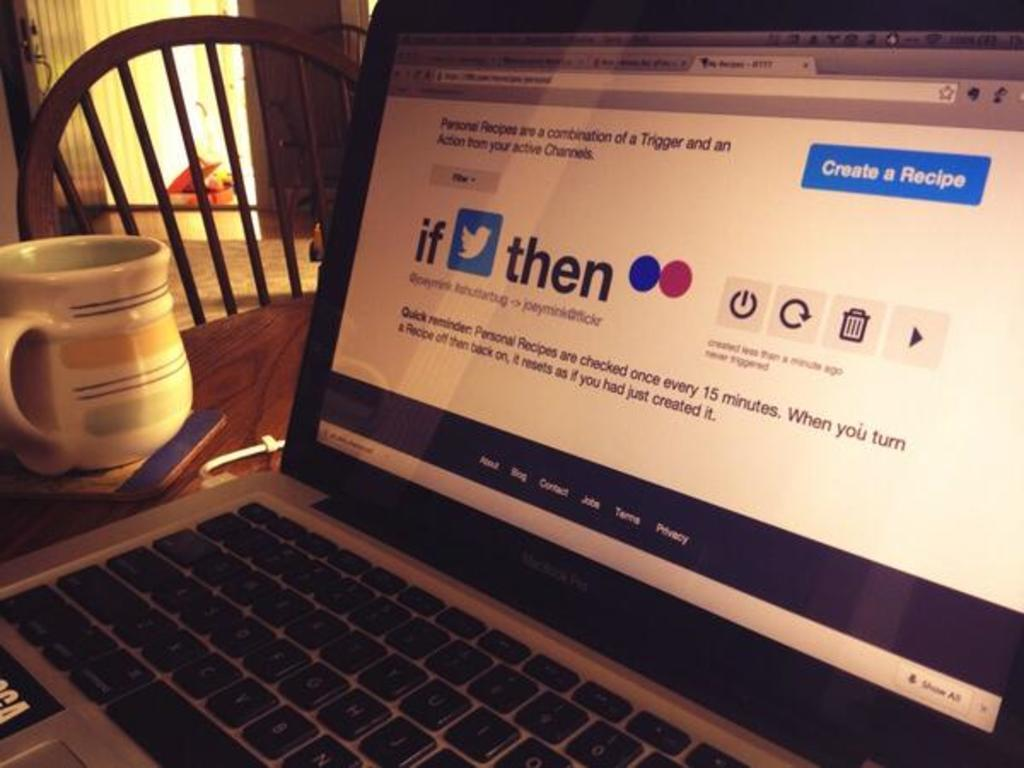What electronic device is visible in the image? There is a laptop in the image. What type of container is present in the image? There is a cup in the image. What piece of furniture is in the image? There is a chair in the image. How is the chair positioned in the image? The chair is on a table in the image. How many pieces of beef are on the table in the image? There is no beef present in the image. What type of clock is visible on the laptop in the image? There is no clock visible on the laptop in the image. 